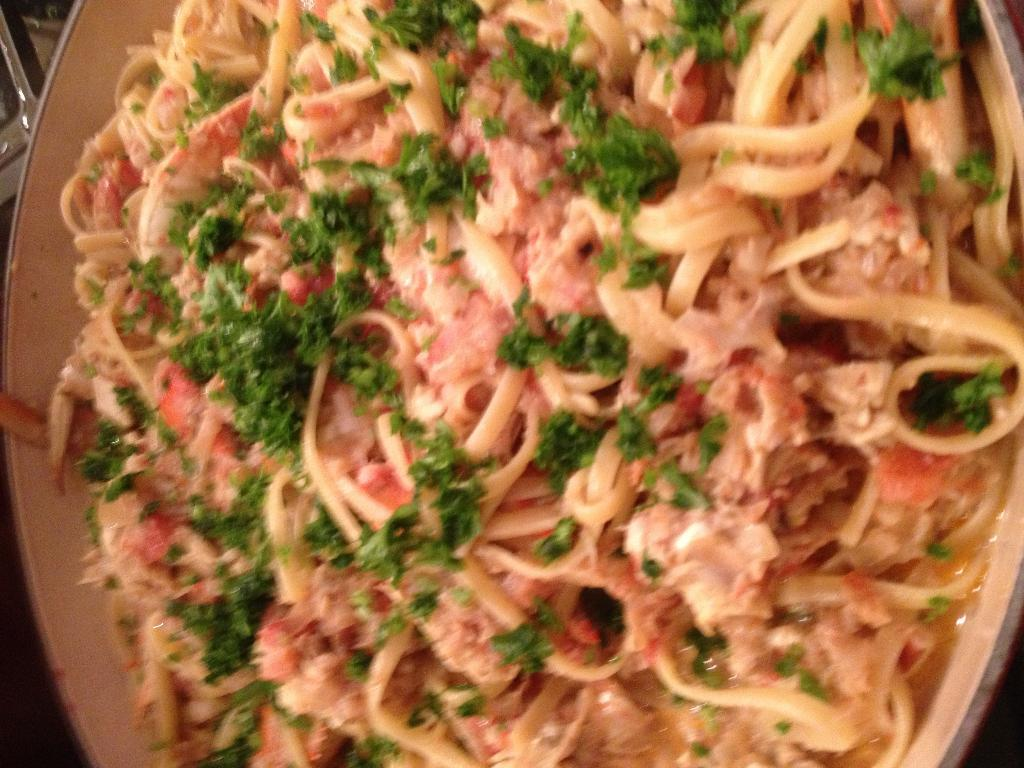What type of dish is visible in the image? There is a curry in the image. What is the main component of the dish in the image? Noodles are present in a bowl. How are the noodles in the bowl prepared or served? The noodles are garnished with herbs. What type of snake can be seen slithering through the curry in the image? There is no snake present in the image; it features a bowl of noodles with herbs. What kind of band is playing music in the background of the image? There is no band or music present in the image; it only shows a bowl of noodles with herbs. 